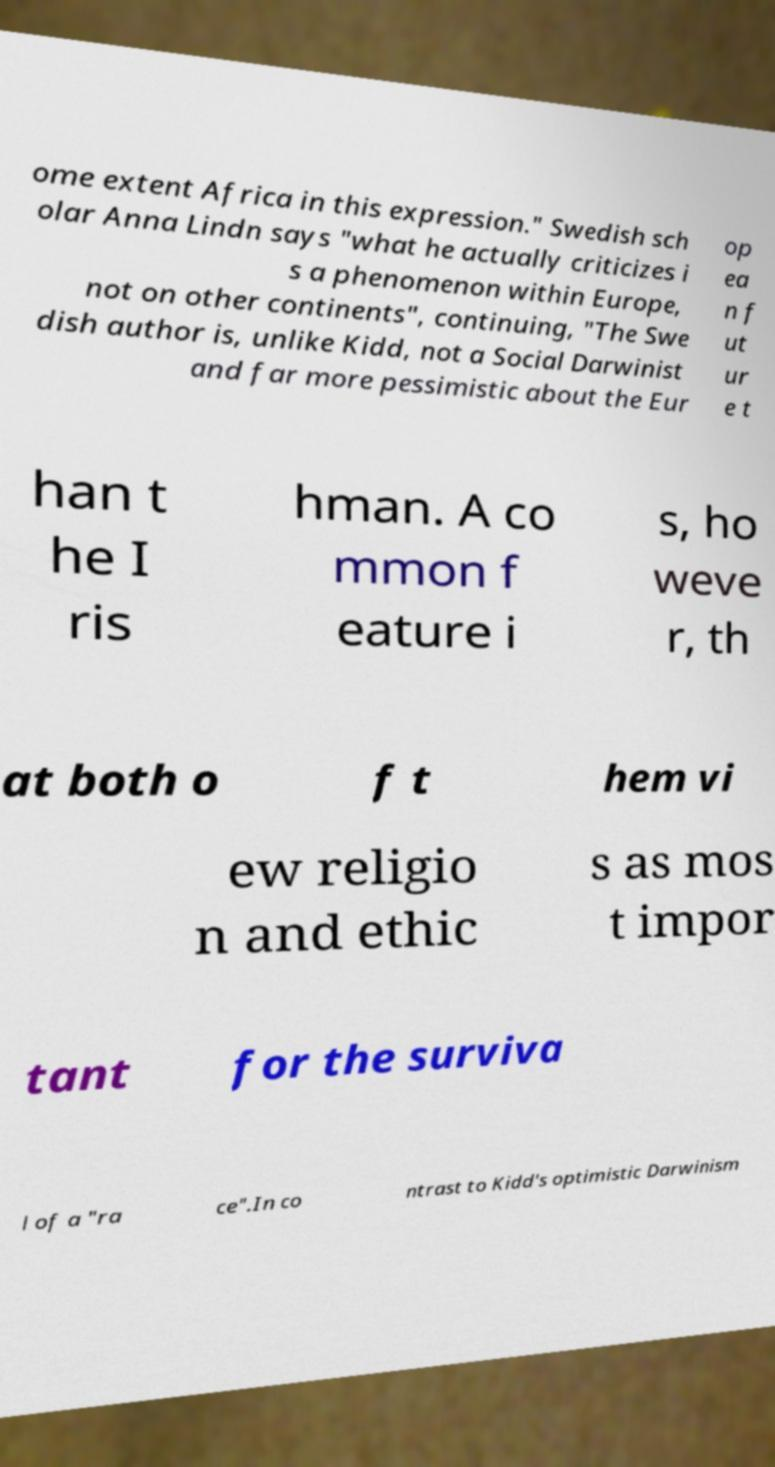Could you assist in decoding the text presented in this image and type it out clearly? ome extent Africa in this expression." Swedish sch olar Anna Lindn says "what he actually criticizes i s a phenomenon within Europe, not on other continents", continuing, "The Swe dish author is, unlike Kidd, not a Social Darwinist and far more pessimistic about the Eur op ea n f ut ur e t han t he I ris hman. A co mmon f eature i s, ho weve r, th at both o f t hem vi ew religio n and ethic s as mos t impor tant for the surviva l of a "ra ce".In co ntrast to Kidd's optimistic Darwinism 